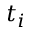Convert formula to latex. <formula><loc_0><loc_0><loc_500><loc_500>t _ { i }</formula> 